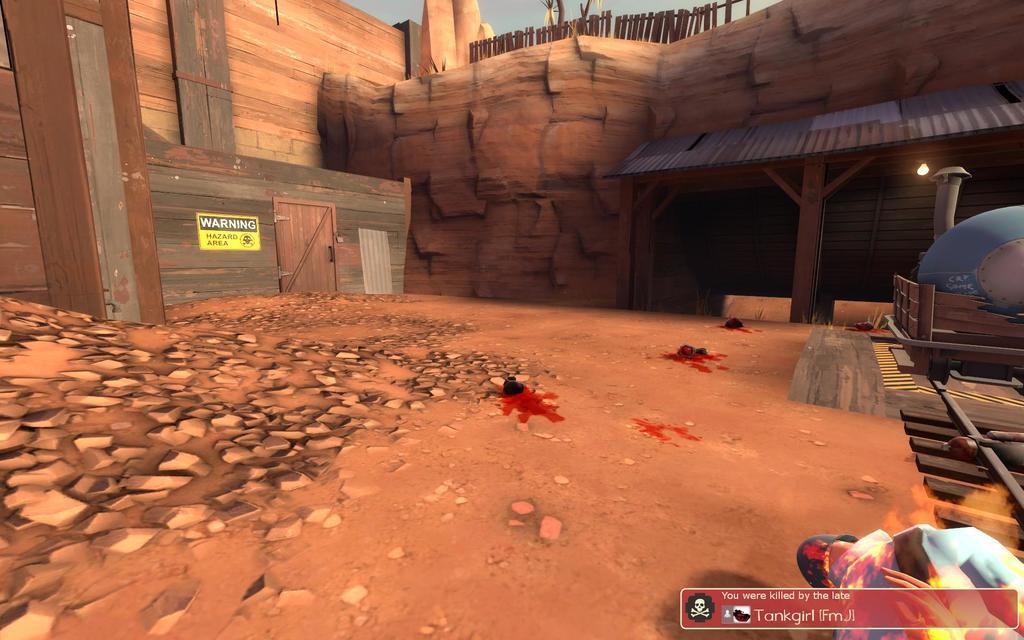Could you give a brief overview of what you see in this image? In this image we can see an animated picture of a house, rocks, there is a board with text on it, also we can see a person, and text on the bottom right corner of the image. 